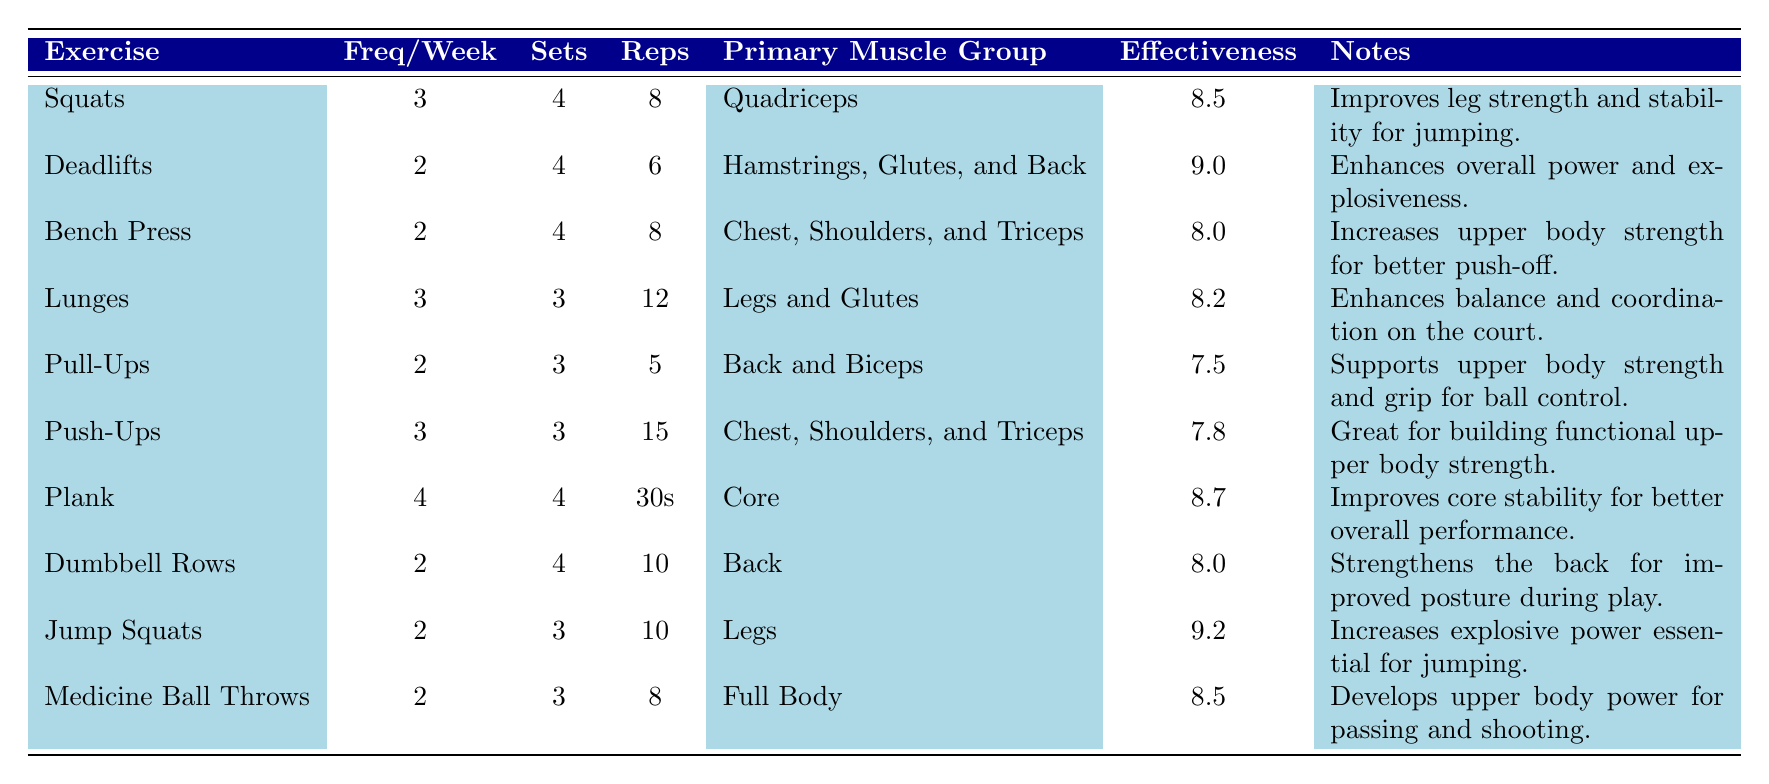What is the effectiveness score of Deadlifts? The effectiveness score for Deadlifts is directly listed in the table. It is stated as 9.0, reflecting its high effectiveness in the strength training program.
Answer: 9.0 How many sets are recommended for Lunges? According to the table, Lunges have 3 sets recommended as part of the strength training program.
Answer: 3 Which exercise has the highest effectiveness score? By examining the effectiveness scores in the table, Jump Squats have the highest score at 9.2, making it the most effective exercise listed.
Answer: Jump Squats What is the average effectiveness score of all exercises listed? The effectiveness scores are 8.5, 9.0, 8.0, 8.2, 7.5, 7.8, 8.7, 8.0, 9.2, and 8.5. Summing them gives 8.5 + 9.0 + 8.0 + 8.2 + 7.5 + 7.8 + 8.7 + 8.0 + 9.2 + 8.5 = 8.57. Dividing this by 10 gives an average of 8.57.
Answer: 8.57 Is the primary muscle group for Pull-Ups Back and Biceps? The table indicates that the primary muscle group for Pull-Ups is indeed Back and Biceps, confirming that this statement is true.
Answer: Yes Which exercise requires the highest frequency per week? Looking at the frequencies, Plank is performed 4 times a week, which is the highest frequency among the listed exercises.
Answer: Plank How many total weekly reps are performed for Push-Ups? Push-Ups consist of 3 sets of 15 reps. Therefore, the total weekly reps equal 3 sets × 15 reps = 45 reps per week.
Answer: 45 Which exercises focus on leg strength? The exercises that focus on leg strength are Squats, Lunges, and Jump Squats. Squats target the Quadriceps, Lunges target Legs and Glutes, and Jump Squats concentrate on Legs.
Answer: Squats, Lunges, Jump Squats Do more exercises focus on upper body strength or lower body strength based on this table? The table lists a total of 5 exercises targeting upper body strength (Bench Press, Pull-Ups, Push-Ups, Dumbbell Rows, and Medicine Ball Throws) and 4 exercises for lower body strength (Squats, Deadlifts, Lunges, and Jump Squats), indicating there are more upper body exercises.
Answer: Upper body strength What is the total number of sets recommended for all exercises combined? The total sets are calculated by summing the sets for each exercise: 4 (Squats) + 4 (Deadlifts) + 4 (Bench Press) + 3 (Lunges) + 3 (Pull-Ups) + 3 (Push-Ups) + 4 (Plank) + 4 (Dumbbell Rows) + 3 (Jump Squats) + 3 (Medicine Ball Throws) =  4 + 4 + 4 + 3 + 3 + 3 + 4 + 4 + 3 + 3 =  38 sets in total.
Answer: 38 